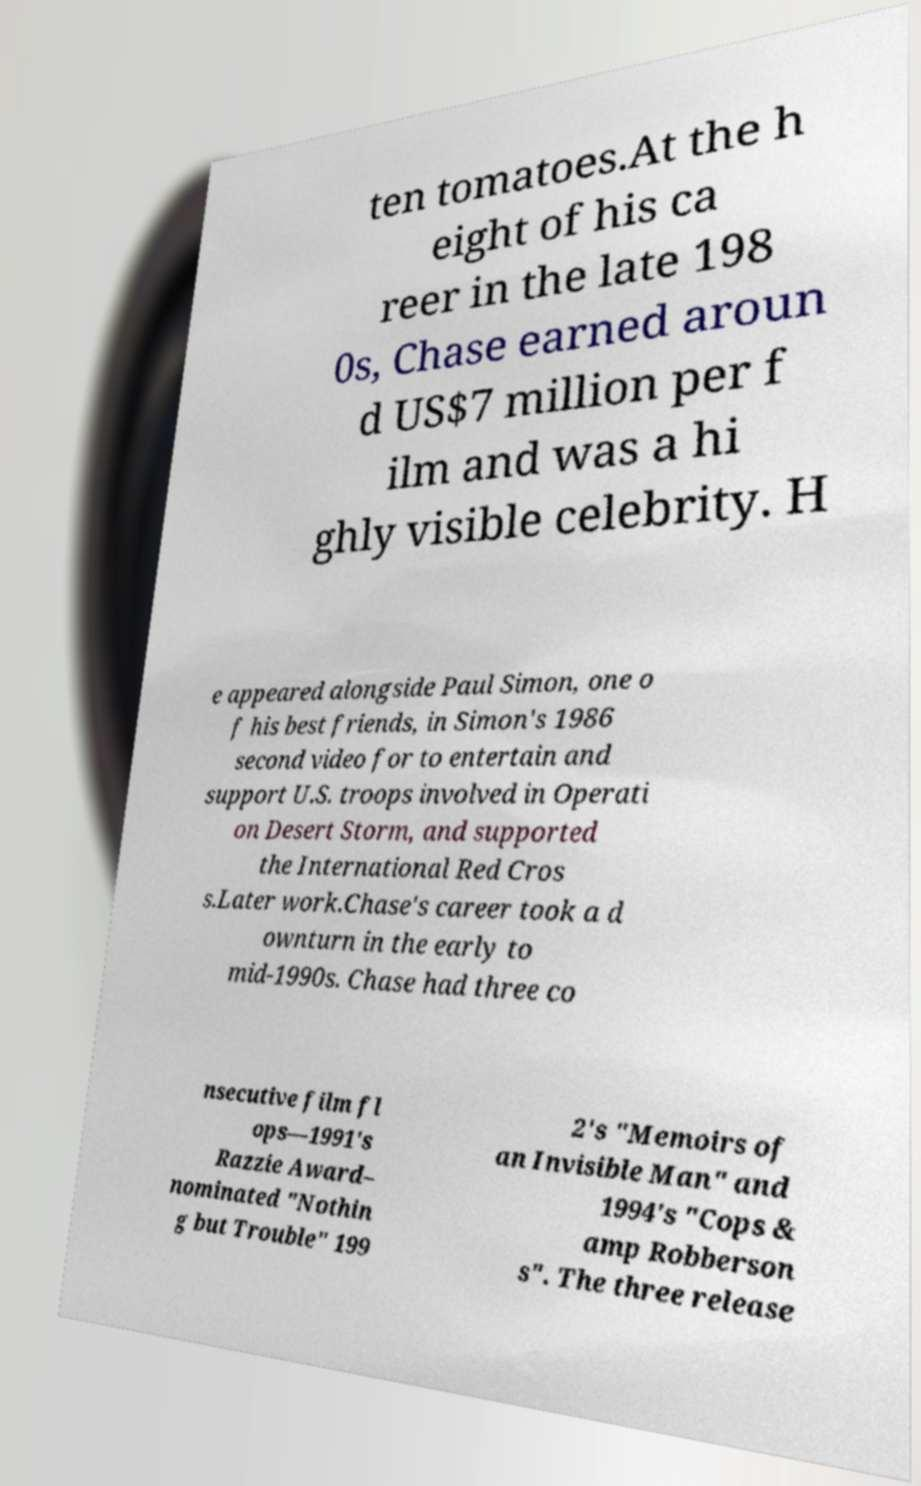There's text embedded in this image that I need extracted. Can you transcribe it verbatim? ten tomatoes.At the h eight of his ca reer in the late 198 0s, Chase earned aroun d US$7 million per f ilm and was a hi ghly visible celebrity. H e appeared alongside Paul Simon, one o f his best friends, in Simon's 1986 second video for to entertain and support U.S. troops involved in Operati on Desert Storm, and supported the International Red Cros s.Later work.Chase's career took a d ownturn in the early to mid-1990s. Chase had three co nsecutive film fl ops—1991's Razzie Award– nominated "Nothin g but Trouble" 199 2's "Memoirs of an Invisible Man" and 1994's "Cops & amp Robberson s". The three release 